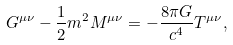Convert formula to latex. <formula><loc_0><loc_0><loc_500><loc_500>G ^ { \mu \nu } - \frac { 1 } { 2 } m ^ { 2 } M ^ { \mu \nu } = - \frac { 8 \pi G } { c ^ { 4 } } T ^ { \mu \nu } ,</formula> 